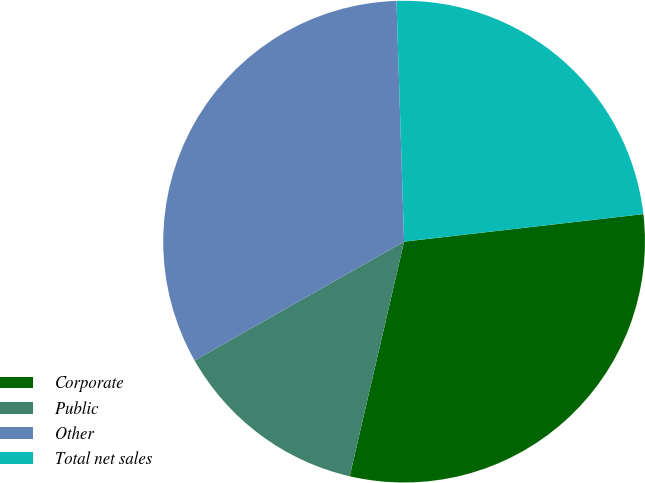Convert chart. <chart><loc_0><loc_0><loc_500><loc_500><pie_chart><fcel>Corporate<fcel>Public<fcel>Other<fcel>Total net sales<nl><fcel>30.45%<fcel>13.16%<fcel>32.71%<fcel>23.68%<nl></chart> 